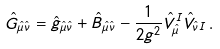Convert formula to latex. <formula><loc_0><loc_0><loc_500><loc_500>\hat { G } _ { \hat { \mu } \hat { \nu } } = \hat { g } _ { \hat { \mu } \hat { \nu } } + \hat { B } _ { \hat { \mu } \hat { \nu } } - { \frac { 1 } { 2 g ^ { 2 } } } \hat { V } _ { \hat { \mu } } ^ { I } \hat { V } _ { \hat { \nu } I } \, .</formula> 